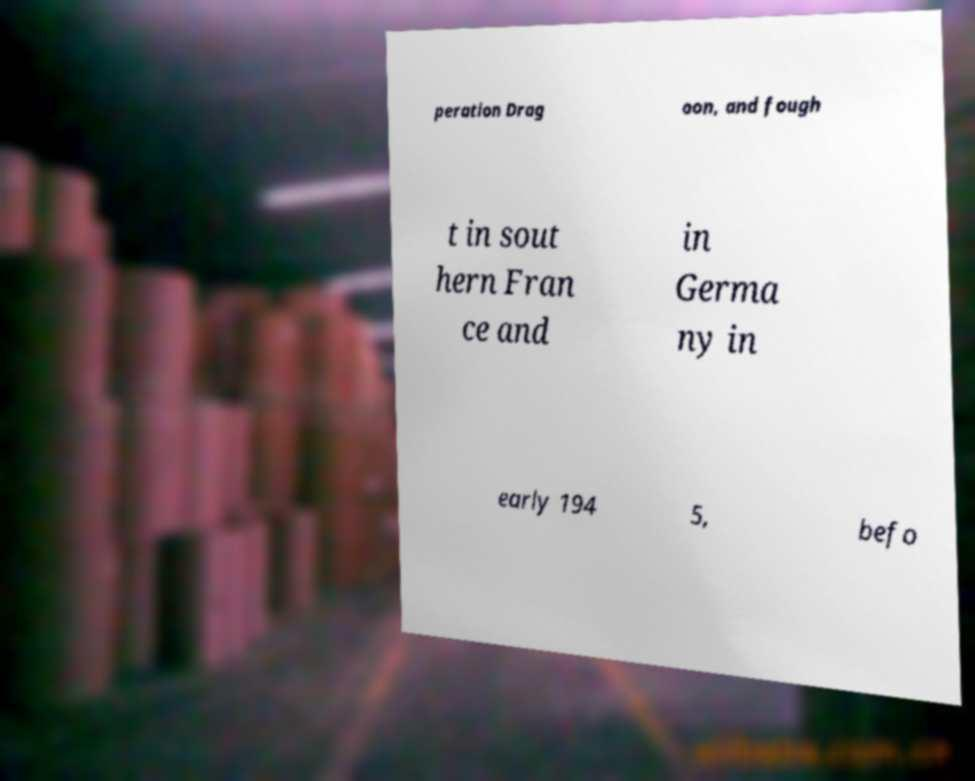For documentation purposes, I need the text within this image transcribed. Could you provide that? peration Drag oon, and fough t in sout hern Fran ce and in Germa ny in early 194 5, befo 